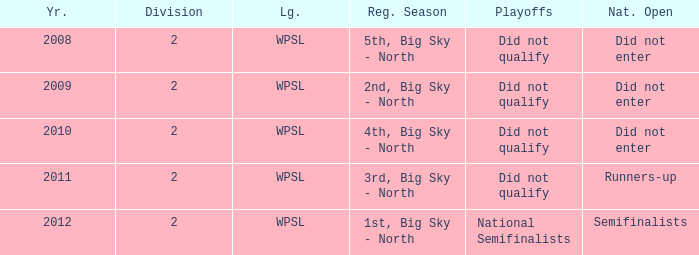What is the highest number of divisions mentioned? 2.0. 